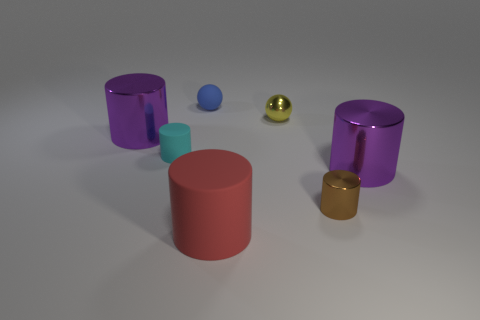Is the color of the tiny rubber cylinder the same as the small metal ball?
Your response must be concise. No. What is the size of the purple metallic object that is on the right side of the purple object that is on the left side of the brown shiny cylinder?
Offer a very short reply. Large. There is a small brown thing that is the same shape as the cyan matte thing; what is it made of?
Offer a very short reply. Metal. What number of tiny matte objects are there?
Offer a terse response. 2. There is a small ball that is on the right side of the blue ball to the left of the small cylinder that is right of the tiny rubber ball; what is its color?
Make the answer very short. Yellow. Are there fewer green cylinders than purple cylinders?
Provide a succinct answer. Yes. There is another small metal thing that is the same shape as the red thing; what color is it?
Provide a succinct answer. Brown. There is a cylinder that is made of the same material as the tiny cyan object; what color is it?
Your answer should be compact. Red. How many cyan matte cylinders have the same size as the yellow ball?
Ensure brevity in your answer.  1. What material is the tiny blue thing?
Your answer should be very brief. Rubber. 